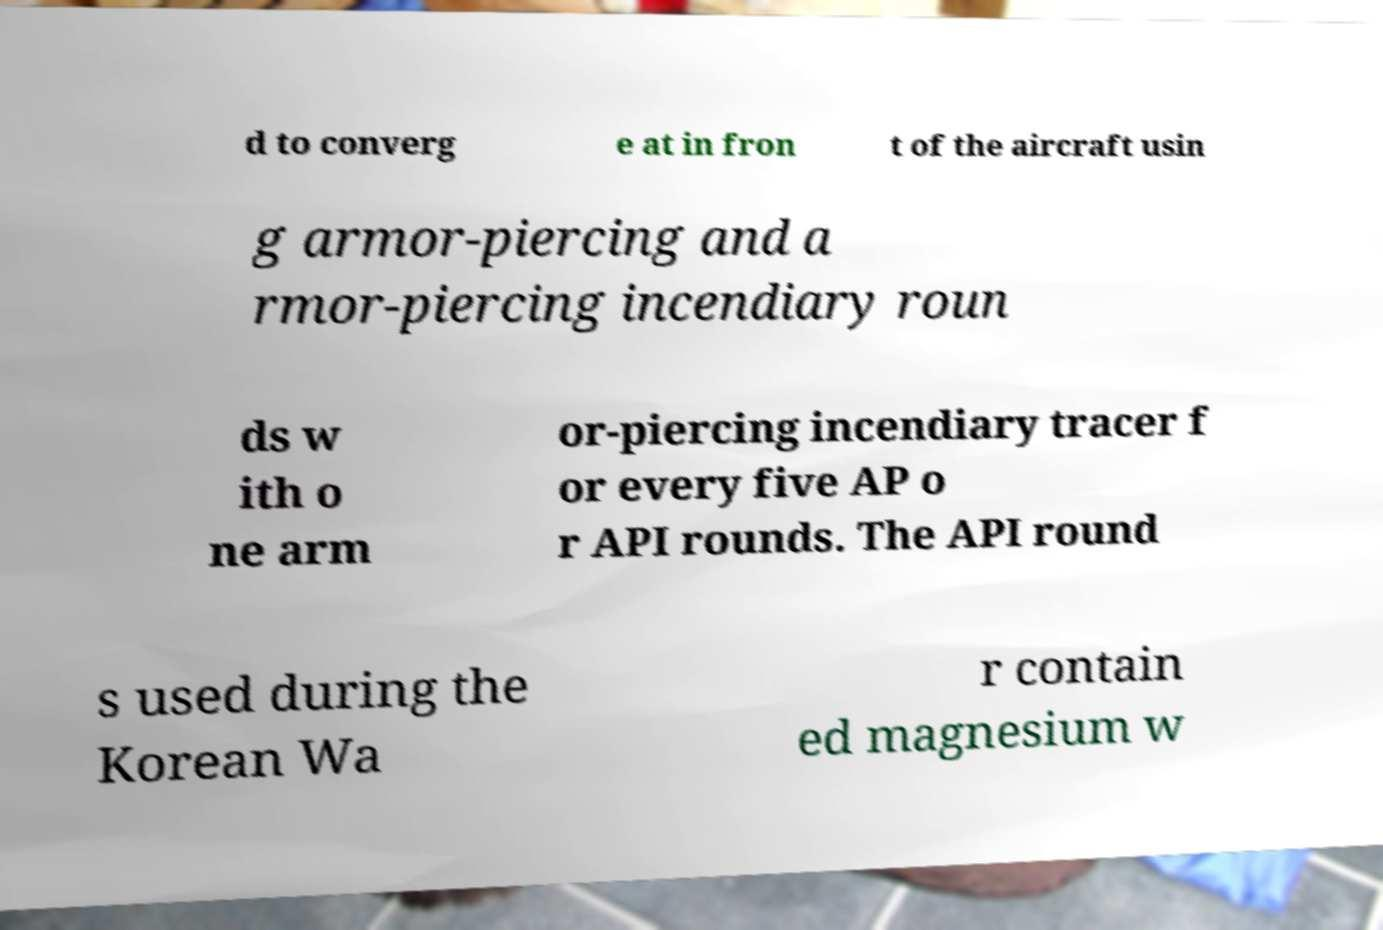Can you accurately transcribe the text from the provided image for me? d to converg e at in fron t of the aircraft usin g armor-piercing and a rmor-piercing incendiary roun ds w ith o ne arm or-piercing incendiary tracer f or every five AP o r API rounds. The API round s used during the Korean Wa r contain ed magnesium w 